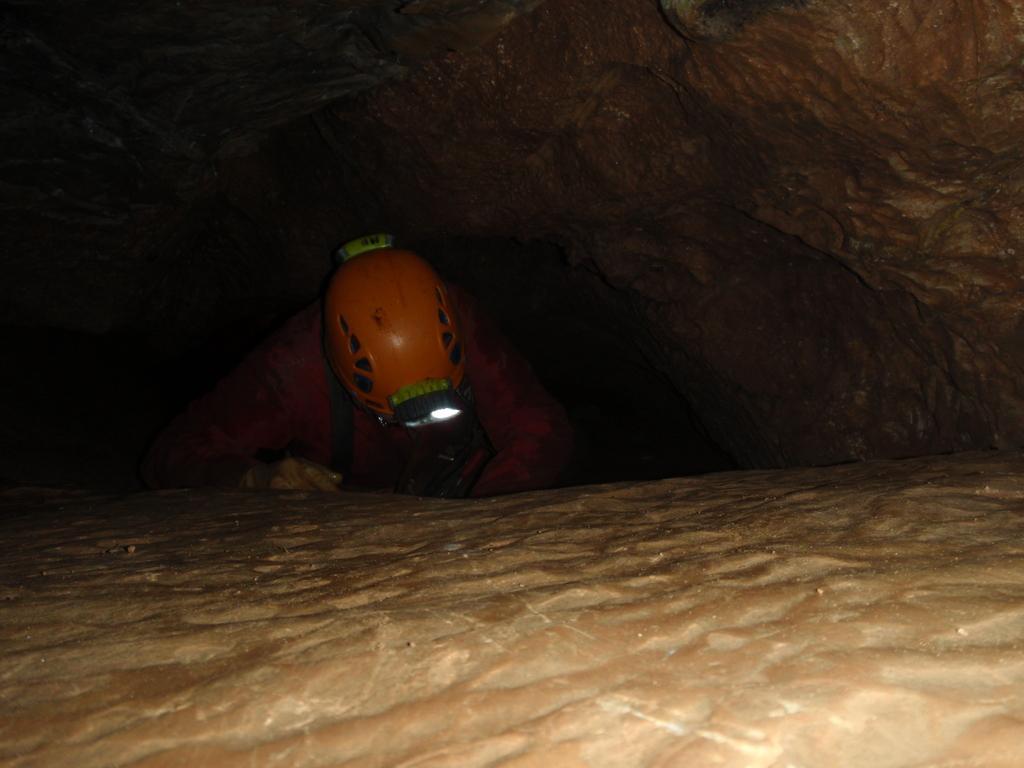In one or two sentences, can you explain what this image depicts? In this image we can see a person wearing helmet standing in between the hills. 